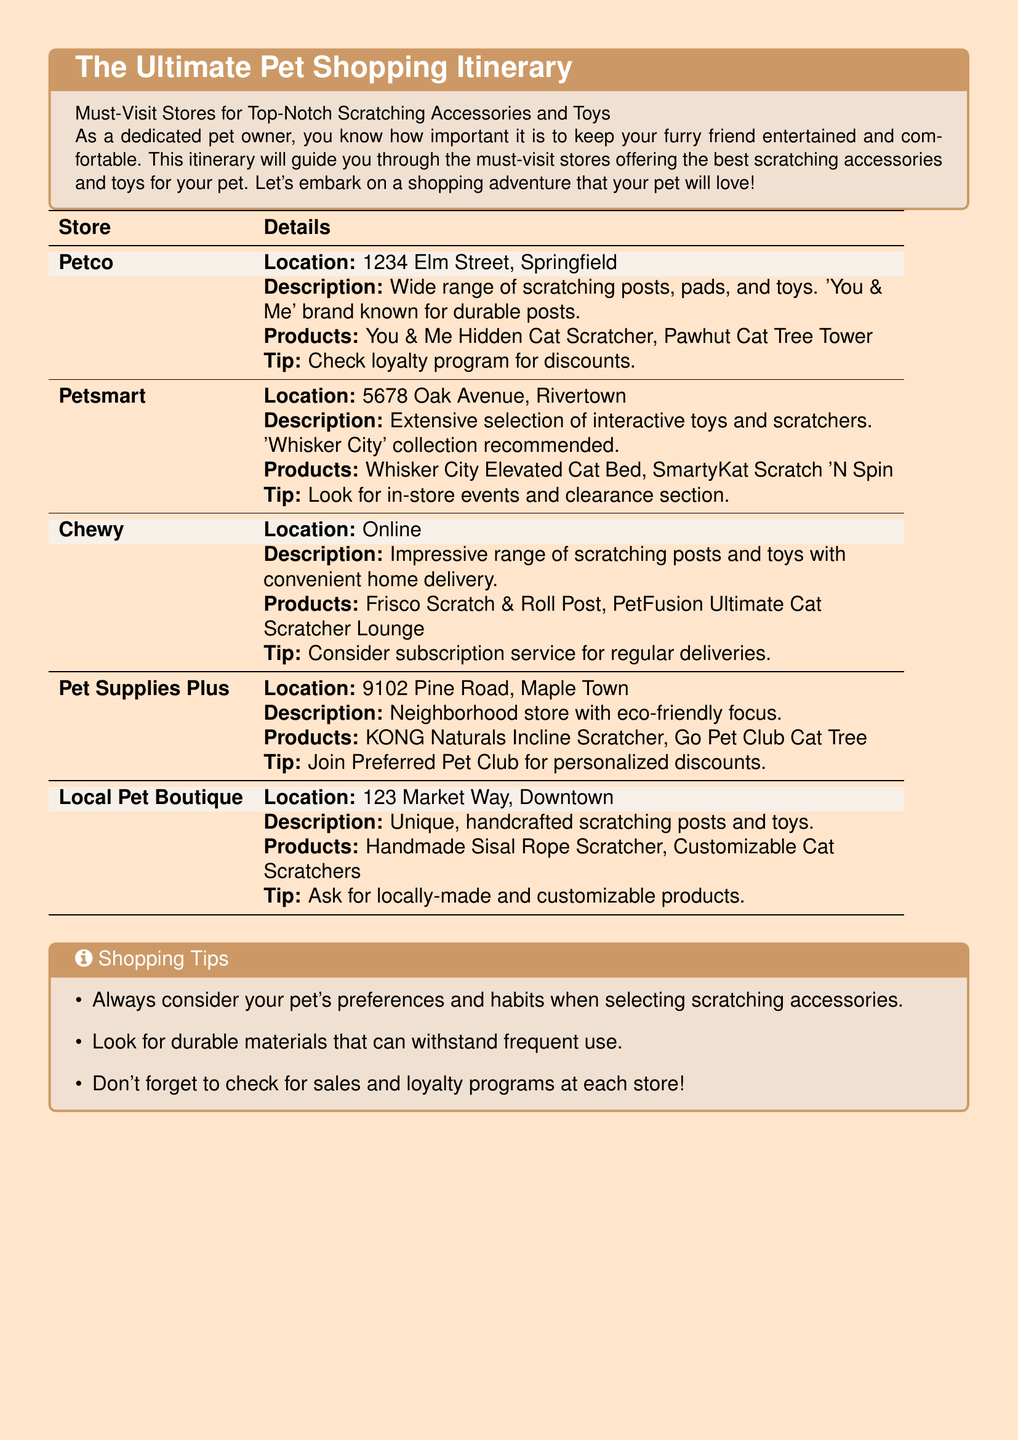What is the location of Petco? Petco is located at 1234 Elm Street, Springfield in the document.
Answer: 1234 Elm Street, Springfield What brand is recommended at Petsmart? The document mentions the 'Whisker City' collection at Petsmart for its extensive selection.
Answer: Whisker City Which store offers a subscription service? Chewy is noted for offering a subscription service for regular deliveries.
Answer: Chewy What is a tip for Pet Supplies Plus? The document advises joining the Preferred Pet Club for personalized discounts at Pet Supplies Plus.
Answer: Join Preferred Pet Club What type of products are sold at the Local Pet Boutique? The Local Pet Boutique specializes in unique, handcrafted scratching posts and toys.
Answer: Handcrafted scratching posts and toys How many stores are listed in the itinerary? The document provides details about five distinct stores focused on pet scratching accessories and toys.
Answer: Five What is a general tip provided in the shopping tips section? The document suggests considering your pet's preferences and habits when selecting scratching accessories.
Answer: Consider your pet's preferences What discount program is available at Petco? The document mentions a loyalty program that offers discounts at Petco.
Answer: Loyalty program What is offered at Chewy? Chewy provides an impressive range of scratching posts and toys with convenient home delivery.
Answer: Home delivery 